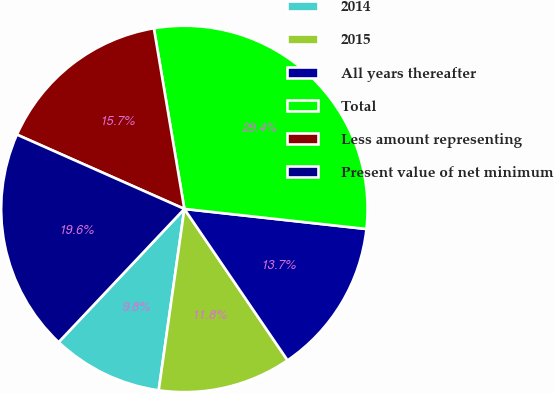<chart> <loc_0><loc_0><loc_500><loc_500><pie_chart><fcel>2014<fcel>2015<fcel>All years thereafter<fcel>Total<fcel>Less amount representing<fcel>Present value of net minimum<nl><fcel>9.8%<fcel>11.76%<fcel>13.73%<fcel>29.41%<fcel>15.69%<fcel>19.61%<nl></chart> 